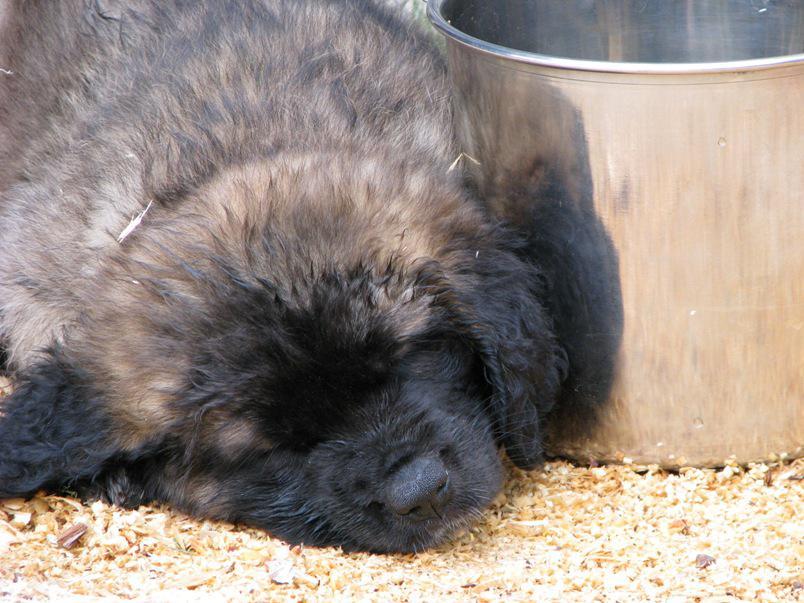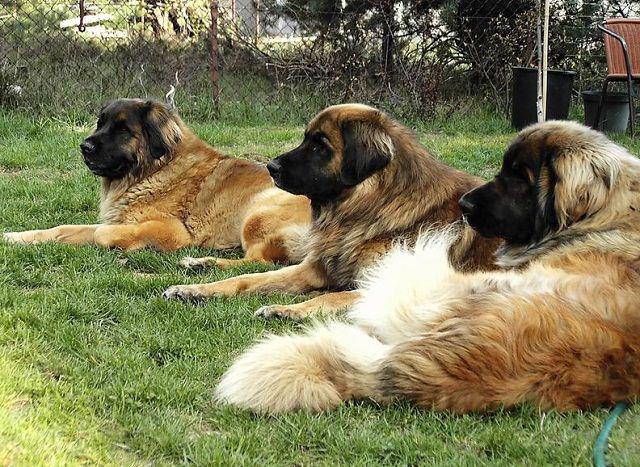The first image is the image on the left, the second image is the image on the right. Assess this claim about the two images: "All of the dogs are outside and some of them are sleeping.". Correct or not? Answer yes or no. Yes. The first image is the image on the left, the second image is the image on the right. Analyze the images presented: Is the assertion "The single dog in the left image appears to be lying down." valid? Answer yes or no. Yes. 